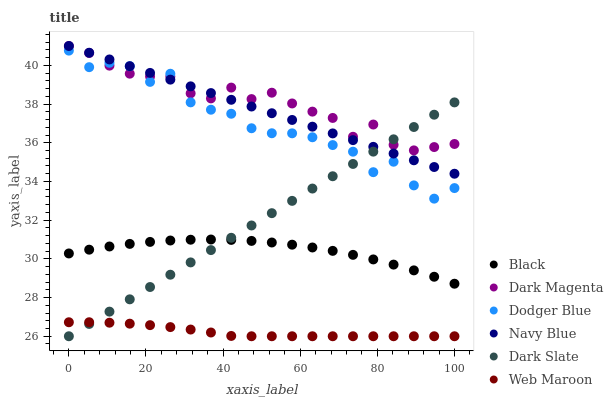Does Web Maroon have the minimum area under the curve?
Answer yes or no. Yes. Does Dark Magenta have the maximum area under the curve?
Answer yes or no. Yes. Does Navy Blue have the minimum area under the curve?
Answer yes or no. No. Does Navy Blue have the maximum area under the curve?
Answer yes or no. No. Is Dark Slate the smoothest?
Answer yes or no. Yes. Is Dodger Blue the roughest?
Answer yes or no. Yes. Is Navy Blue the smoothest?
Answer yes or no. No. Is Navy Blue the roughest?
Answer yes or no. No. Does Web Maroon have the lowest value?
Answer yes or no. Yes. Does Navy Blue have the lowest value?
Answer yes or no. No. Does Navy Blue have the highest value?
Answer yes or no. Yes. Does Web Maroon have the highest value?
Answer yes or no. No. Is Black less than Dark Magenta?
Answer yes or no. Yes. Is Dodger Blue greater than Web Maroon?
Answer yes or no. Yes. Does Dodger Blue intersect Dark Slate?
Answer yes or no. Yes. Is Dodger Blue less than Dark Slate?
Answer yes or no. No. Is Dodger Blue greater than Dark Slate?
Answer yes or no. No. Does Black intersect Dark Magenta?
Answer yes or no. No. 